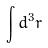Convert formula to latex. <formula><loc_0><loc_0><loc_500><loc_500>\int d ^ { 3 } r</formula> 